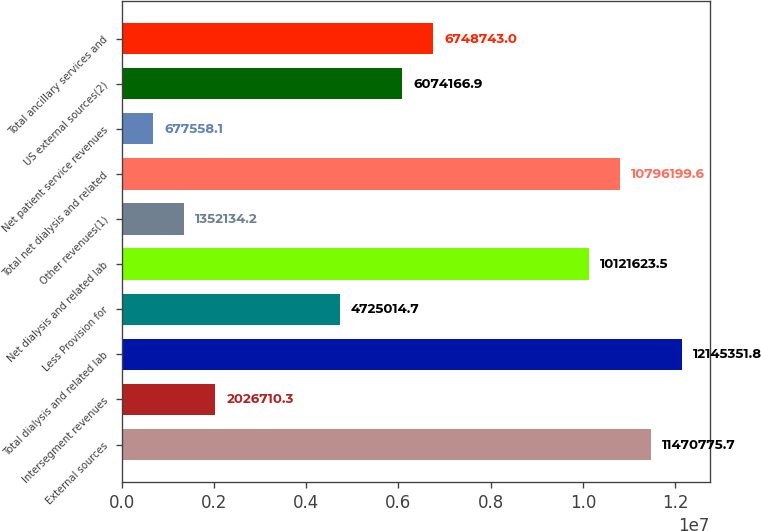<chart> <loc_0><loc_0><loc_500><loc_500><bar_chart><fcel>External sources<fcel>Intersegment revenues<fcel>Total dialysis and related lab<fcel>Less Provision for<fcel>Net dialysis and related lab<fcel>Other revenues(1)<fcel>Total net dialysis and related<fcel>Net patient service revenues<fcel>US external sources(2)<fcel>Total ancillary services and<nl><fcel>1.14708e+07<fcel>2.02671e+06<fcel>1.21454e+07<fcel>4.72501e+06<fcel>1.01216e+07<fcel>1.35213e+06<fcel>1.07962e+07<fcel>677558<fcel>6.07417e+06<fcel>6.74874e+06<nl></chart> 